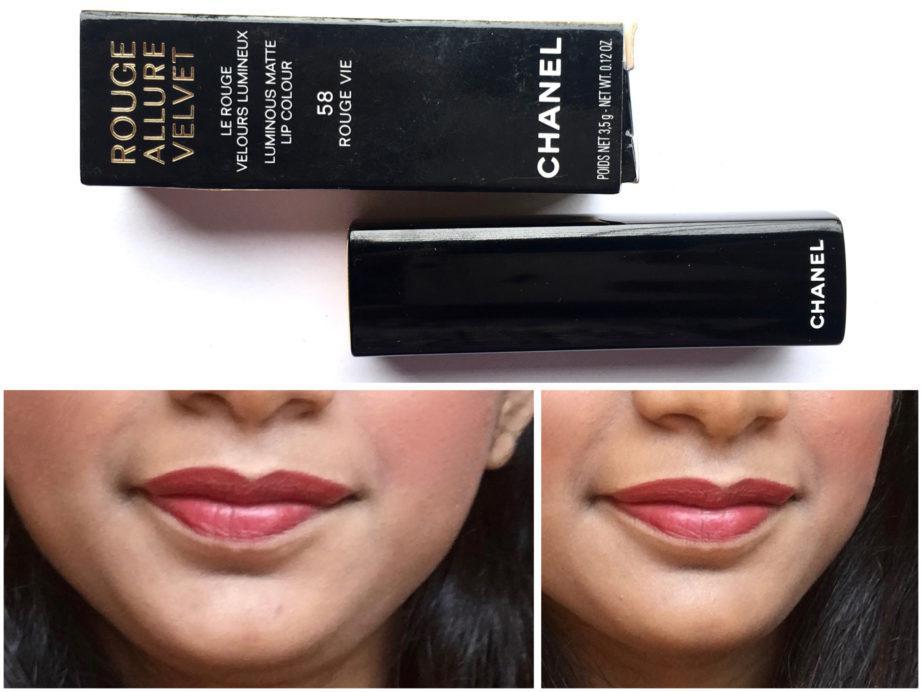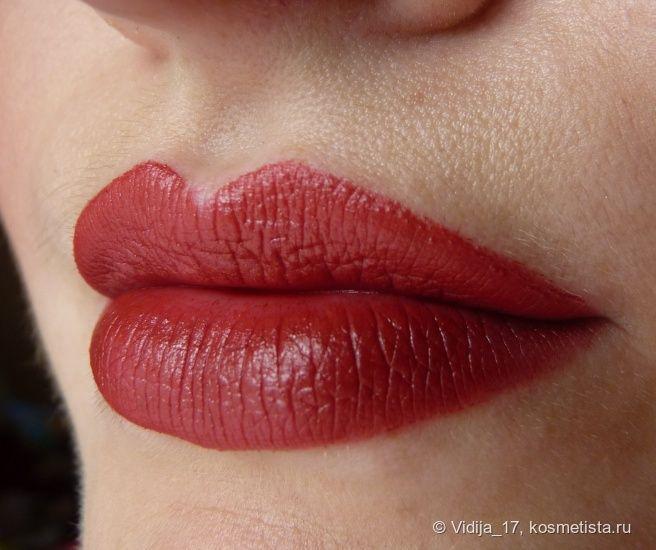The first image is the image on the left, the second image is the image on the right. Examine the images to the left and right. Is the description "A single pair of lips is wearing lipstick in each of the images." accurate? Answer yes or no. No. The first image is the image on the left, the second image is the image on the right. Analyze the images presented: Is the assertion "One image includes a lip makeup item and at least one pair of tinted lips, and the other image contains at least one pair of tinted lips but no lip makeup item." valid? Answer yes or no. Yes. 